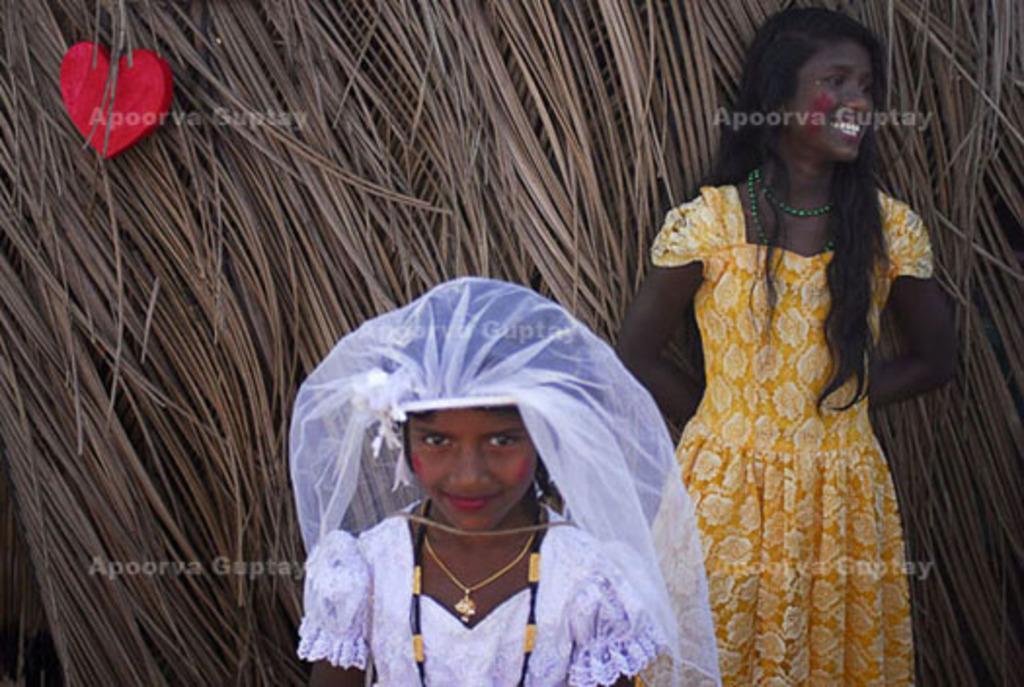Could you give a brief overview of what you see in this image? In this image, there are a few people. In the background, we can see some dried coconut leaves with an object. 